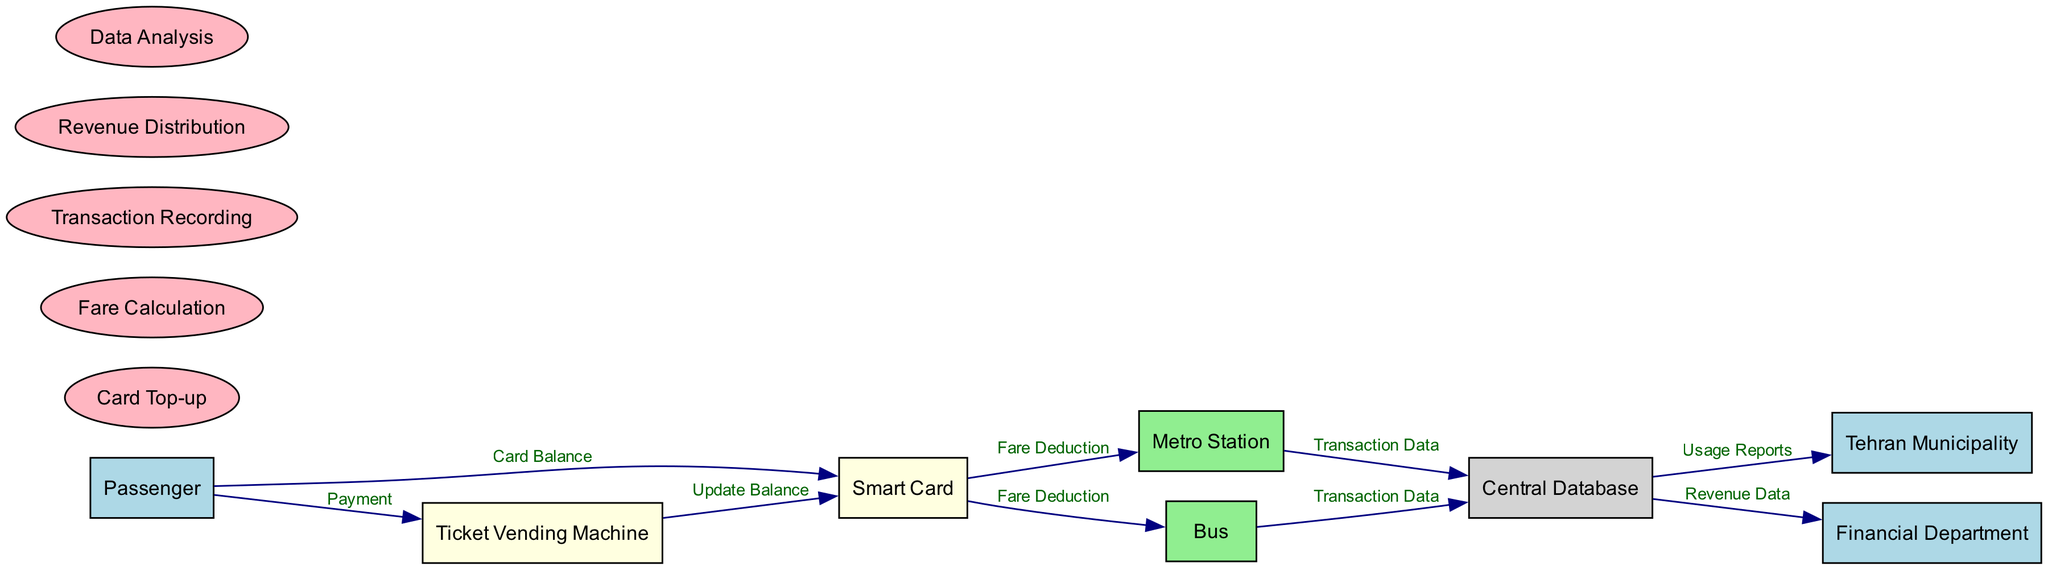What entity receives Usage Reports from the Central Database? The flow indicates that the Usage Reports are sent from the Central Database to the Tehran Municipality. This can be observed by tracing the connection from the Central Database to the Tehran Municipality in the diagram.
Answer: Tehran Municipality How many entities are involved in this diagram? By counting the listed entities: Passenger, Smart Card, Ticket Vending Machine, Metro Station, Bus, Central Database, Tehran Municipality, and Financial Department, we find a total of eight distinct entities.
Answer: 8 What is the first process a Passenger engages in? The Passenger starts the flow by interacting with the Smart Card to input or check their Card Balance, as shown in the flow from the Passenger to the Smart Card.
Answer: Card Top-up Which two processes are involved in the flow of transaction data? The Ticket Vending Machine and the bus both send Transaction Data to the Central Database, making them key processes in the transaction data flow. This can be seen in the two directed flows from these entities to the Central Database.
Answer: Transaction Recording What type of data does the Central Database send to the Financial Department? The data sent from the Central Database to the Financial Department is labeled as Revenue Data, which represents the financial aspect of the transactions. This connection can be identified in the diagram.
Answer: Revenue Data Which entity sends Fare Deduction to the Bus? The Smart Card sends Fare Deduction data to the Bus, which can be noted from the directed flow in the diagram. The connection shows that the Smart Card is responsible for deducting the fare when accessing the bus service.
Answer: Smart Card How many data flows are depicted in the diagram? A count of the data flows listed reveals that there are nine distinct connections flowing from various entities to others, representing different stages in collecting and distributing public transportation fare.
Answer: 9 What is the last process in the flow regarding revenue? Revenue Distribution is the last process represented in the flow connected to the financial aspect, indicating the final step in distributing collected fares. Though it appears to be a process, it indicates the culmination of all data collected.
Answer: Revenue Distribution 